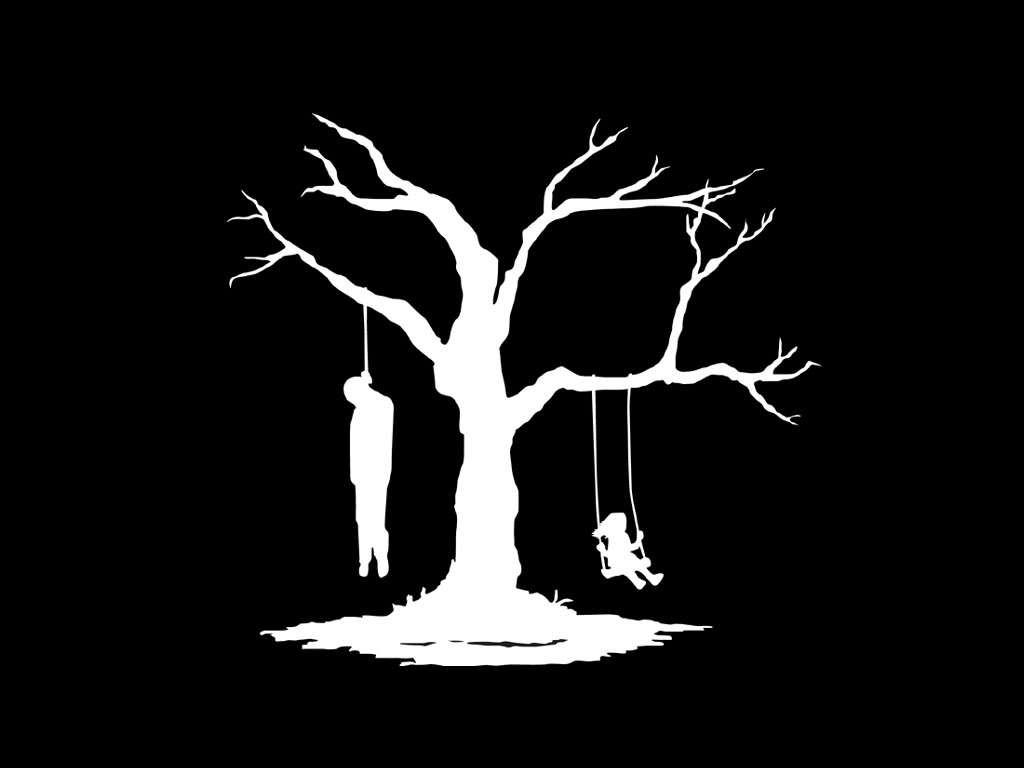What is present in the image? There is a tree in the image. What is happening to the man in the image? A man is hanged from the tree. What activity is the girl engaged in? A girl is swinging from the tree. What type of tooth is visible in the image? There is no tooth present in the image. What is the girl's desire while swinging from the tree? The image does not provide information about the girl's desires, only her actions. 